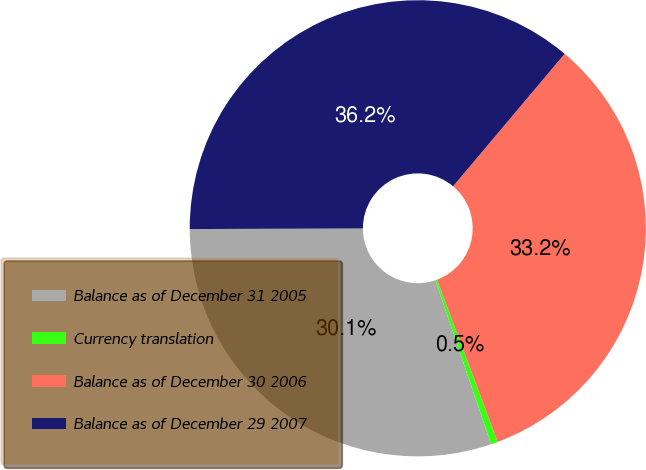Convert chart to OTSL. <chart><loc_0><loc_0><loc_500><loc_500><pie_chart><fcel>Balance as of December 31 2005<fcel>Currency translation<fcel>Balance as of December 30 2006<fcel>Balance as of December 29 2007<nl><fcel>30.15%<fcel>0.49%<fcel>33.17%<fcel>36.19%<nl></chart> 